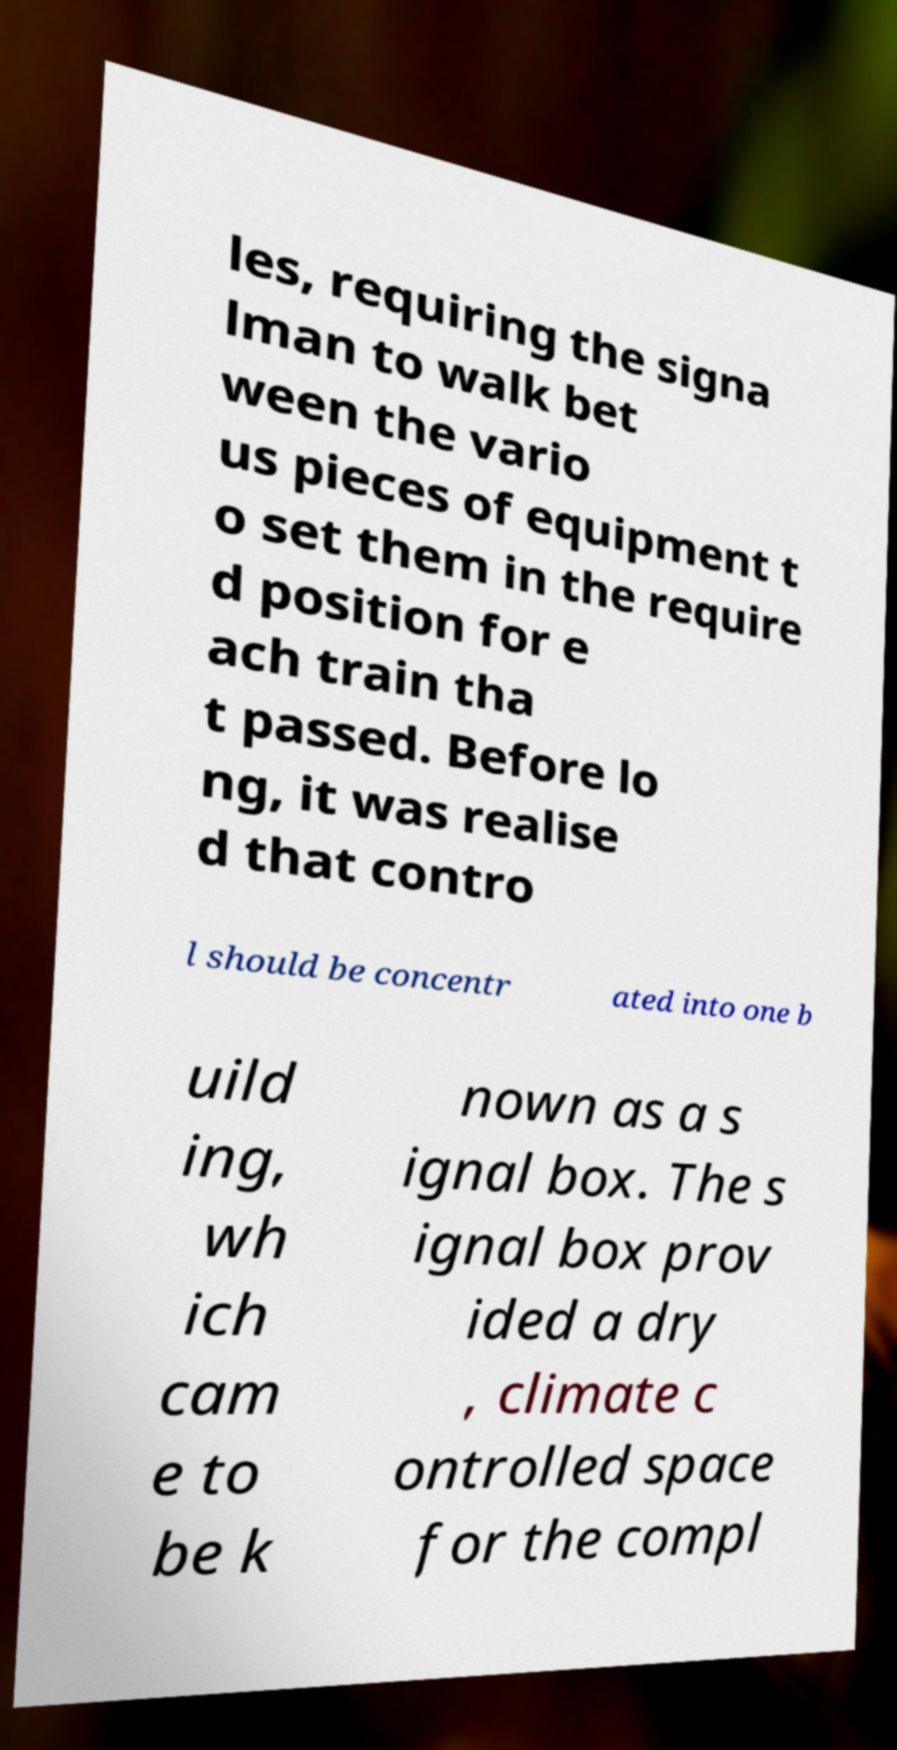I need the written content from this picture converted into text. Can you do that? les, requiring the signa lman to walk bet ween the vario us pieces of equipment t o set them in the require d position for e ach train tha t passed. Before lo ng, it was realise d that contro l should be concentr ated into one b uild ing, wh ich cam e to be k nown as a s ignal box. The s ignal box prov ided a dry , climate c ontrolled space for the compl 